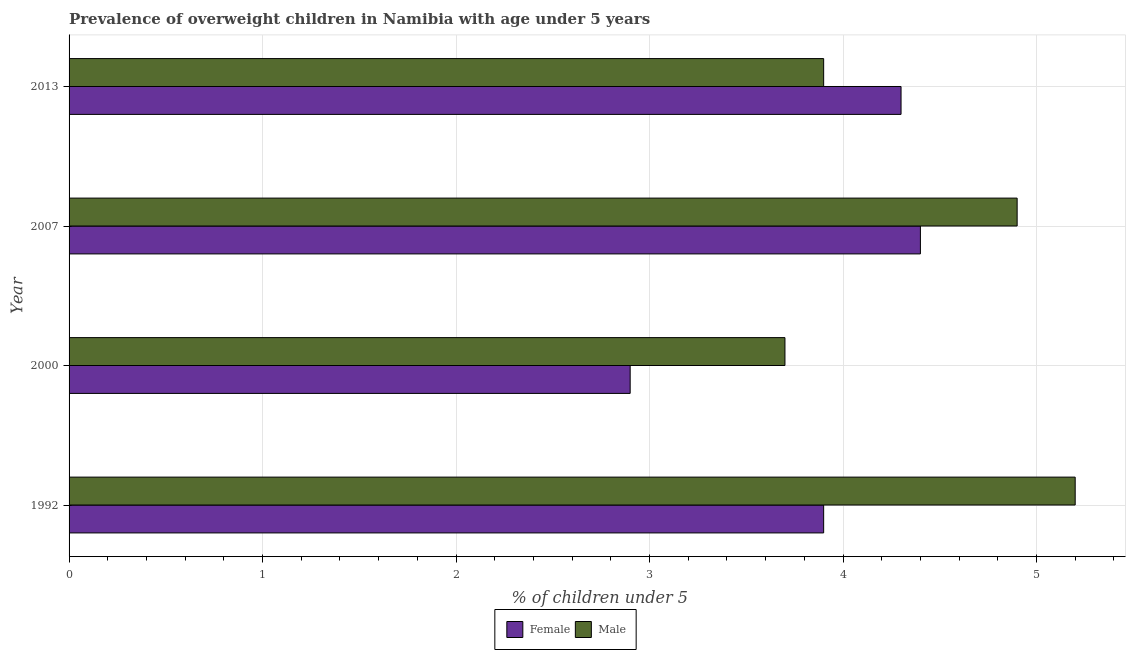Are the number of bars on each tick of the Y-axis equal?
Ensure brevity in your answer.  Yes. How many bars are there on the 1st tick from the top?
Provide a short and direct response. 2. How many bars are there on the 1st tick from the bottom?
Give a very brief answer. 2. What is the label of the 4th group of bars from the top?
Offer a very short reply. 1992. What is the percentage of obese female children in 2007?
Ensure brevity in your answer.  4.4. Across all years, what is the maximum percentage of obese female children?
Your answer should be very brief. 4.4. Across all years, what is the minimum percentage of obese male children?
Give a very brief answer. 3.7. In which year was the percentage of obese male children maximum?
Your answer should be very brief. 1992. In which year was the percentage of obese female children minimum?
Make the answer very short. 2000. What is the total percentage of obese female children in the graph?
Your answer should be compact. 15.5. What is the difference between the percentage of obese female children in 2000 and that in 2013?
Your response must be concise. -1.4. What is the difference between the percentage of obese male children in 2000 and the percentage of obese female children in 2013?
Make the answer very short. -0.6. What is the average percentage of obese female children per year?
Offer a terse response. 3.88. In how many years, is the percentage of obese male children greater than 5 %?
Your answer should be very brief. 1. What is the ratio of the percentage of obese female children in 2000 to that in 2013?
Your answer should be compact. 0.67. Is the percentage of obese male children in 1992 less than that in 2000?
Offer a very short reply. No. Is the difference between the percentage of obese female children in 1992 and 2013 greater than the difference between the percentage of obese male children in 1992 and 2013?
Your response must be concise. No. What is the difference between the highest and the second highest percentage of obese female children?
Give a very brief answer. 0.1. Is the sum of the percentage of obese male children in 2000 and 2013 greater than the maximum percentage of obese female children across all years?
Offer a terse response. Yes. How many bars are there?
Make the answer very short. 8. Are all the bars in the graph horizontal?
Your answer should be very brief. Yes. How many years are there in the graph?
Make the answer very short. 4. What is the difference between two consecutive major ticks on the X-axis?
Your answer should be compact. 1. Where does the legend appear in the graph?
Ensure brevity in your answer.  Bottom center. How many legend labels are there?
Your answer should be very brief. 2. What is the title of the graph?
Your response must be concise. Prevalence of overweight children in Namibia with age under 5 years. Does "Methane emissions" appear as one of the legend labels in the graph?
Offer a terse response. No. What is the label or title of the X-axis?
Keep it short and to the point.  % of children under 5. What is the label or title of the Y-axis?
Your response must be concise. Year. What is the  % of children under 5 of Female in 1992?
Keep it short and to the point. 3.9. What is the  % of children under 5 in Male in 1992?
Keep it short and to the point. 5.2. What is the  % of children under 5 of Female in 2000?
Provide a succinct answer. 2.9. What is the  % of children under 5 of Male in 2000?
Provide a succinct answer. 3.7. What is the  % of children under 5 in Female in 2007?
Give a very brief answer. 4.4. What is the  % of children under 5 in Male in 2007?
Ensure brevity in your answer.  4.9. What is the  % of children under 5 in Female in 2013?
Your answer should be compact. 4.3. What is the  % of children under 5 of Male in 2013?
Provide a short and direct response. 3.9. Across all years, what is the maximum  % of children under 5 of Female?
Provide a short and direct response. 4.4. Across all years, what is the maximum  % of children under 5 of Male?
Provide a succinct answer. 5.2. Across all years, what is the minimum  % of children under 5 of Female?
Your answer should be compact. 2.9. Across all years, what is the minimum  % of children under 5 of Male?
Offer a very short reply. 3.7. What is the total  % of children under 5 of Female in the graph?
Your response must be concise. 15.5. What is the difference between the  % of children under 5 of Female in 1992 and that in 2000?
Offer a very short reply. 1. What is the difference between the  % of children under 5 in Male in 1992 and that in 2000?
Your answer should be compact. 1.5. What is the difference between the  % of children under 5 of Male in 2000 and that in 2007?
Offer a terse response. -1.2. What is the difference between the  % of children under 5 of Female in 2000 and that in 2013?
Provide a short and direct response. -1.4. What is the difference between the  % of children under 5 of Male in 2000 and that in 2013?
Your answer should be very brief. -0.2. What is the difference between the  % of children under 5 of Male in 2007 and that in 2013?
Give a very brief answer. 1. What is the difference between the  % of children under 5 of Female in 1992 and the  % of children under 5 of Male in 2000?
Provide a succinct answer. 0.2. What is the difference between the  % of children under 5 in Female in 1992 and the  % of children under 5 in Male in 2013?
Your answer should be compact. 0. What is the average  % of children under 5 of Female per year?
Provide a short and direct response. 3.88. What is the average  % of children under 5 of Male per year?
Your response must be concise. 4.42. In the year 1992, what is the difference between the  % of children under 5 of Female and  % of children under 5 of Male?
Provide a short and direct response. -1.3. In the year 2000, what is the difference between the  % of children under 5 of Female and  % of children under 5 of Male?
Make the answer very short. -0.8. What is the ratio of the  % of children under 5 in Female in 1992 to that in 2000?
Give a very brief answer. 1.34. What is the ratio of the  % of children under 5 of Male in 1992 to that in 2000?
Your answer should be compact. 1.41. What is the ratio of the  % of children under 5 in Female in 1992 to that in 2007?
Offer a very short reply. 0.89. What is the ratio of the  % of children under 5 of Male in 1992 to that in 2007?
Provide a succinct answer. 1.06. What is the ratio of the  % of children under 5 of Female in 1992 to that in 2013?
Your answer should be very brief. 0.91. What is the ratio of the  % of children under 5 in Male in 1992 to that in 2013?
Provide a short and direct response. 1.33. What is the ratio of the  % of children under 5 in Female in 2000 to that in 2007?
Provide a short and direct response. 0.66. What is the ratio of the  % of children under 5 in Male in 2000 to that in 2007?
Provide a succinct answer. 0.76. What is the ratio of the  % of children under 5 of Female in 2000 to that in 2013?
Give a very brief answer. 0.67. What is the ratio of the  % of children under 5 in Male in 2000 to that in 2013?
Your answer should be very brief. 0.95. What is the ratio of the  % of children under 5 in Female in 2007 to that in 2013?
Your answer should be compact. 1.02. What is the ratio of the  % of children under 5 of Male in 2007 to that in 2013?
Ensure brevity in your answer.  1.26. What is the difference between the highest and the second highest  % of children under 5 in Female?
Your answer should be very brief. 0.1. 